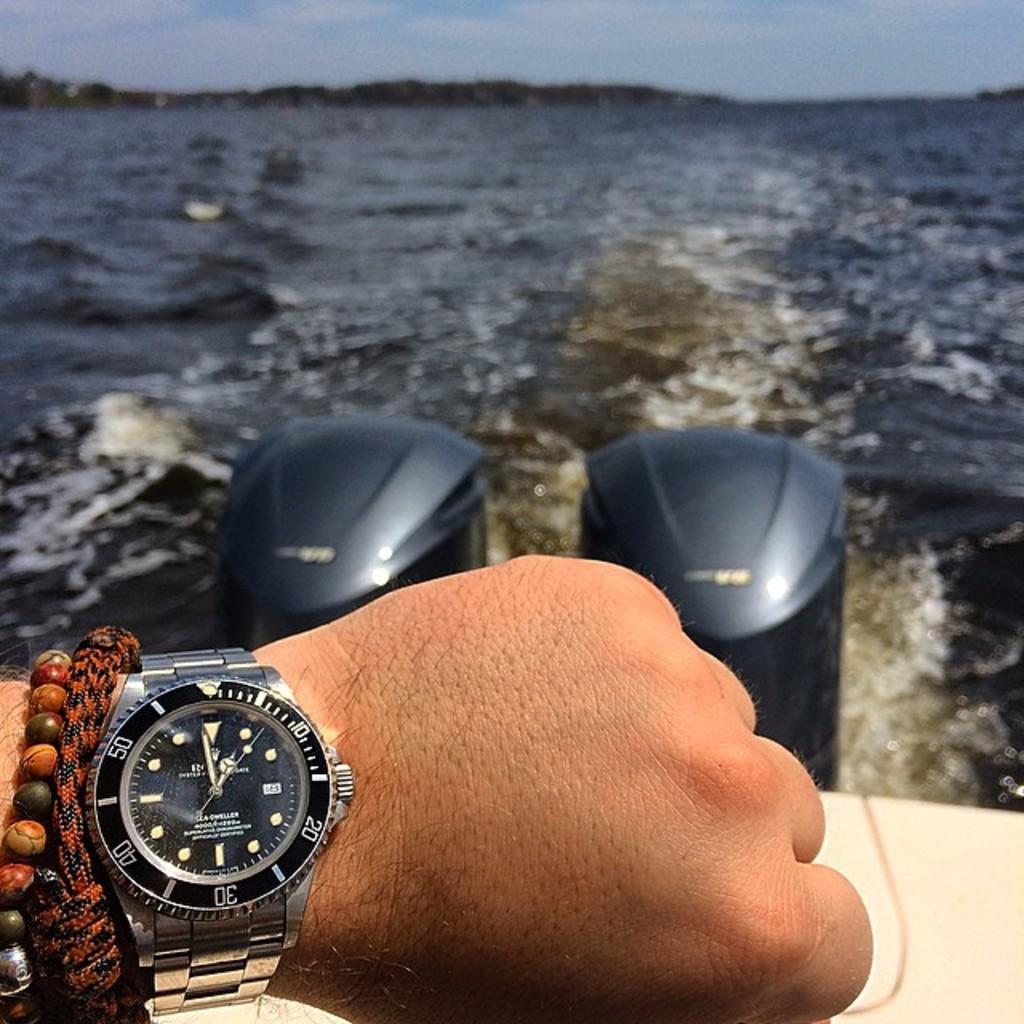<image>
Offer a succinct explanation of the picture presented. Someone is on a boat wearing bracelets and a rolex watch. 